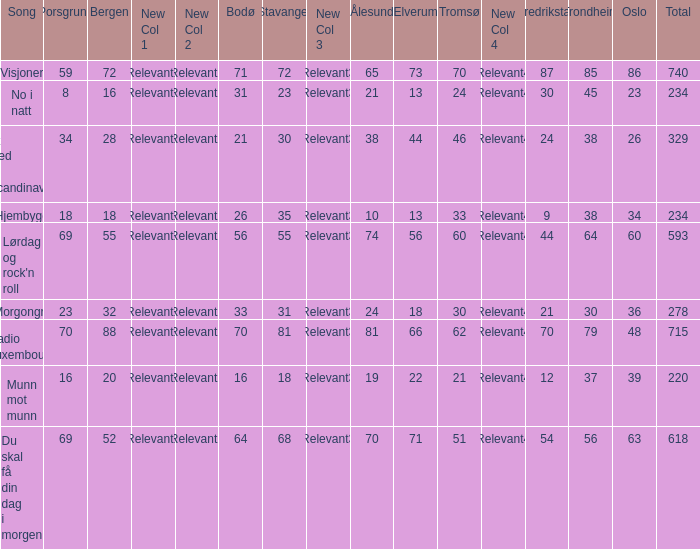When the total score is 740, what is tromso? 70.0. 